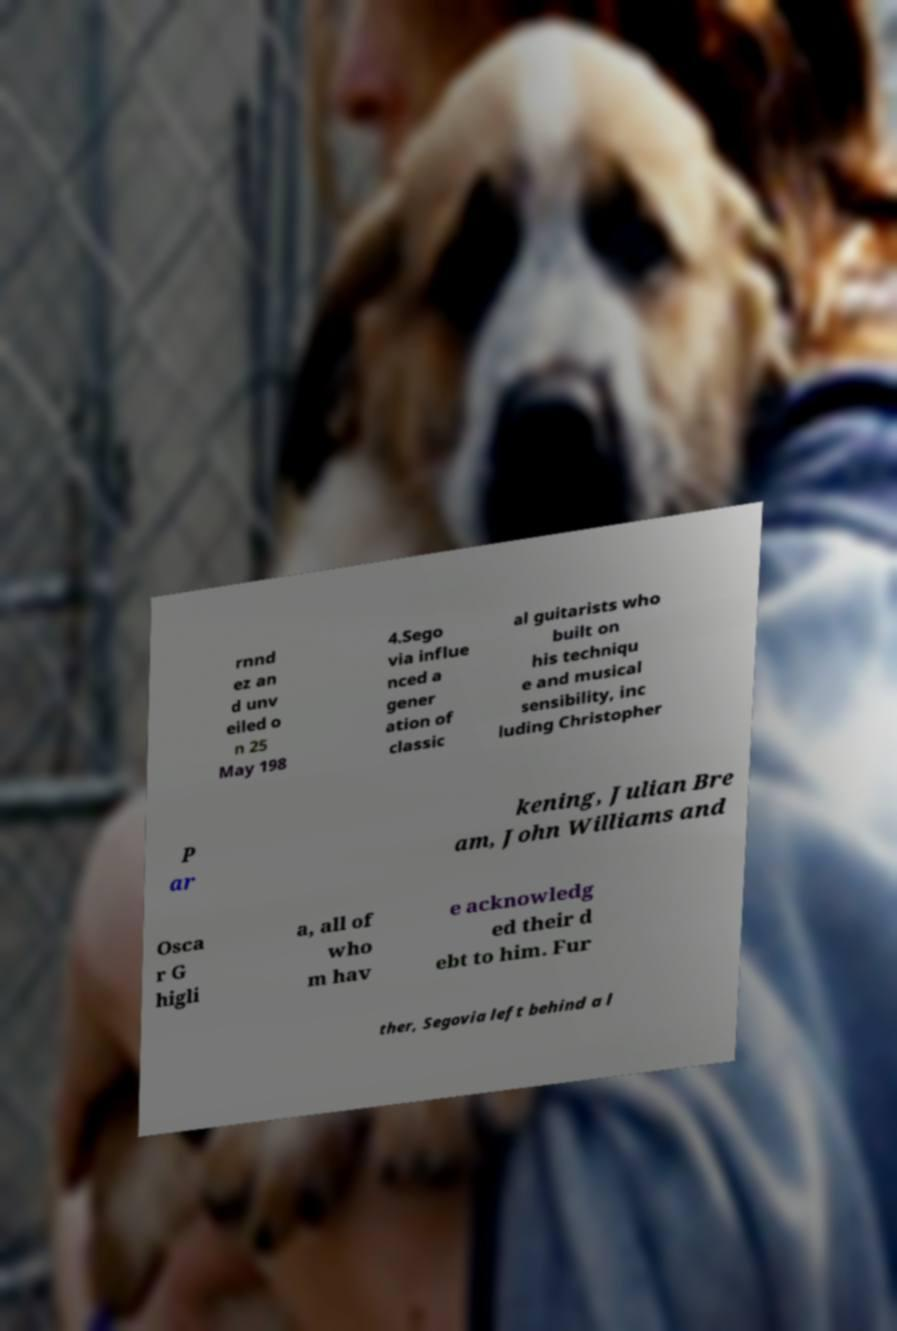What messages or text are displayed in this image? I need them in a readable, typed format. rnnd ez an d unv eiled o n 25 May 198 4.Sego via influe nced a gener ation of classic al guitarists who built on his techniqu e and musical sensibility, inc luding Christopher P ar kening, Julian Bre am, John Williams and Osca r G higli a, all of who m hav e acknowledg ed their d ebt to him. Fur ther, Segovia left behind a l 